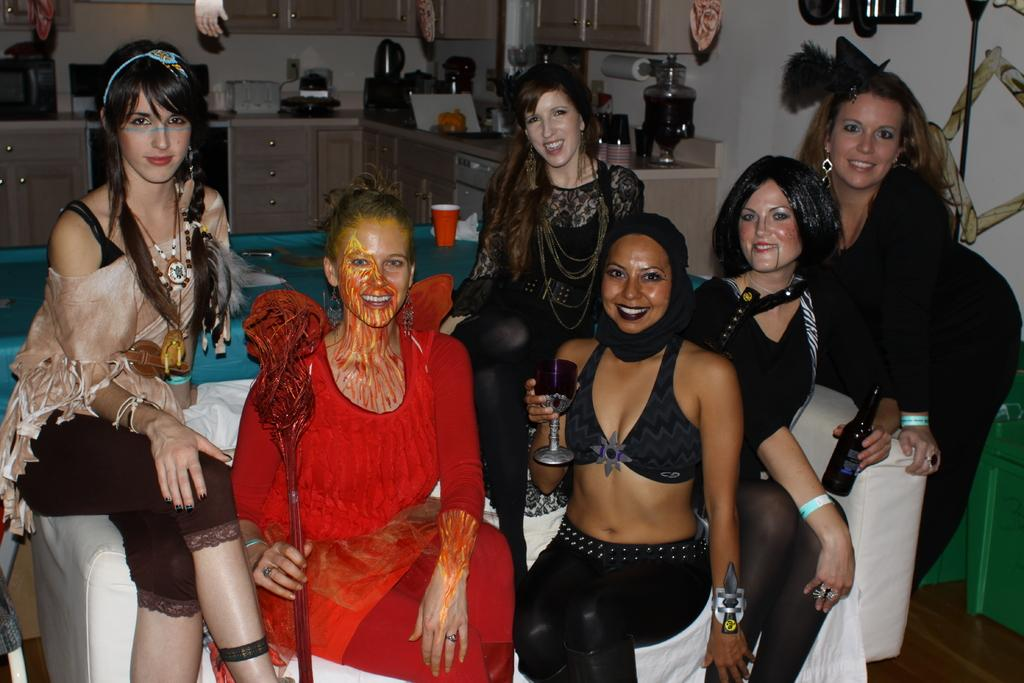What is the main subject of the image? The main subject of the image is a group of girls. What are the girls doing in the image? The girls are sitting on a sofa. Can you describe any specific actions or objects held by the girls? Yes, there is a girl holding a wine glass in her hand. What type of bulb is visible in the image? There is no bulb present in the image. What is the profit made by the girls in the image? The image does not provide any information about profits made by the girls. 